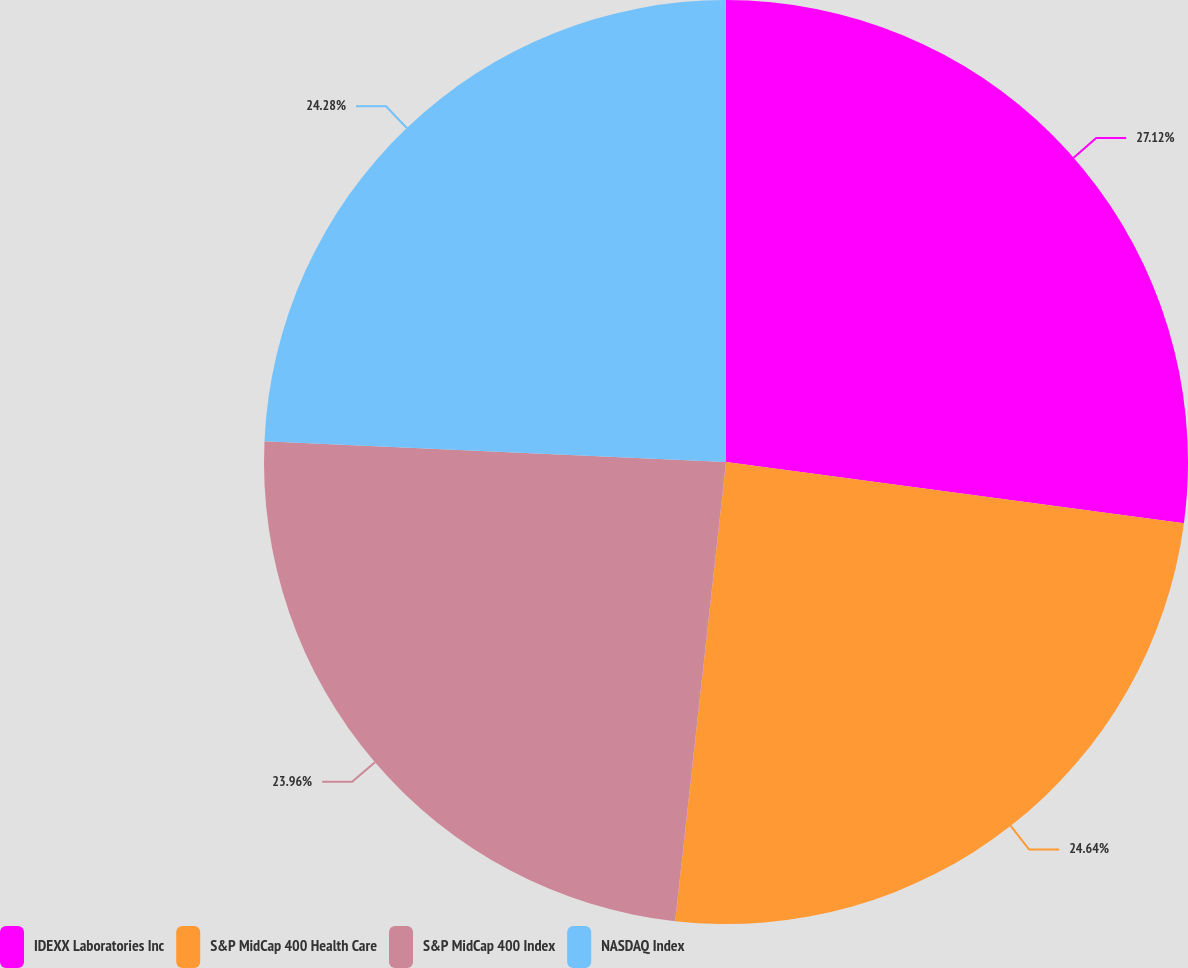Convert chart to OTSL. <chart><loc_0><loc_0><loc_500><loc_500><pie_chart><fcel>IDEXX Laboratories Inc<fcel>S&P MidCap 400 Health Care<fcel>S&P MidCap 400 Index<fcel>NASDAQ Index<nl><fcel>27.11%<fcel>24.64%<fcel>23.96%<fcel>24.28%<nl></chart> 